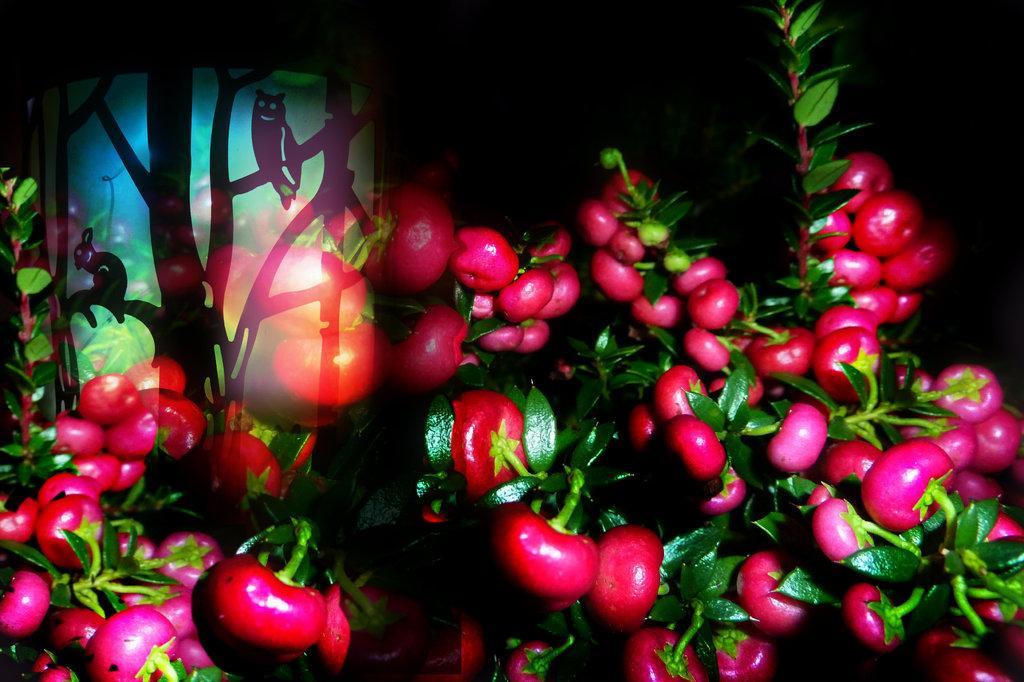How would you summarize this image in a sentence or two? In this image I can see pink color fruits visible on plants 